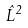Convert formula to latex. <formula><loc_0><loc_0><loc_500><loc_500>\hat { L } ^ { 2 }</formula> 